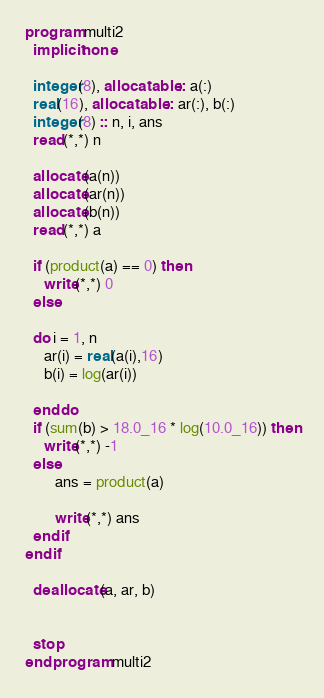<code> <loc_0><loc_0><loc_500><loc_500><_FORTRAN_>program multi2
  implicit none

  integer(8), allocatable :: a(:)
  real(16), allocatable :: ar(:), b(:)
  integer(8) :: n, i, ans
  read(*,*) n

  allocate(a(n))
  allocate(ar(n))
  allocate(b(n))
  read(*,*) a

  if (product(a) == 0) then
     write(*,*) 0
  else
     
  do i = 1, n
     ar(i) = real(a(i),16)
     b(i) = log(ar(i))

  end do
  if (sum(b) > 18.0_16 * log(10.0_16)) then
     write(*,*) -1
  else
        ans = product(a)

        write(*,*) ans
  end if
end if

  deallocate(a, ar, b)

  
  stop
end program multi2



</code> 